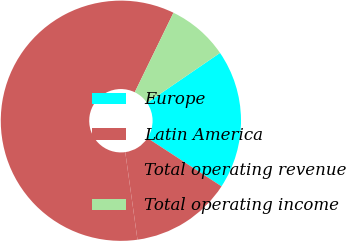Convert chart to OTSL. <chart><loc_0><loc_0><loc_500><loc_500><pie_chart><fcel>Europe<fcel>Latin America<fcel>Total operating revenue<fcel>Total operating income<nl><fcel>18.75%<fcel>13.6%<fcel>59.42%<fcel>8.24%<nl></chart> 